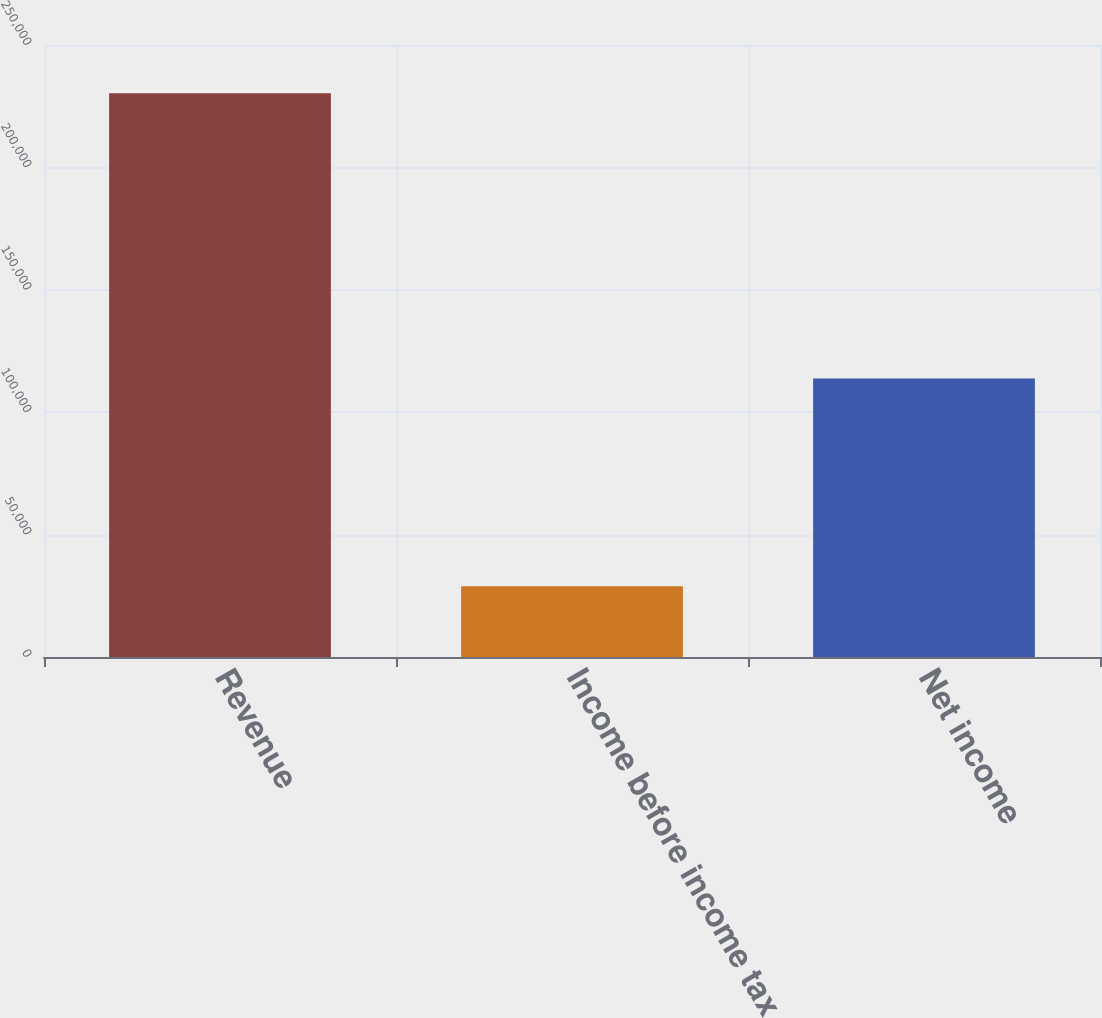<chart> <loc_0><loc_0><loc_500><loc_500><bar_chart><fcel>Revenue<fcel>Income before income tax<fcel>Net income<nl><fcel>230323<fcel>28871<fcel>113794<nl></chart> 